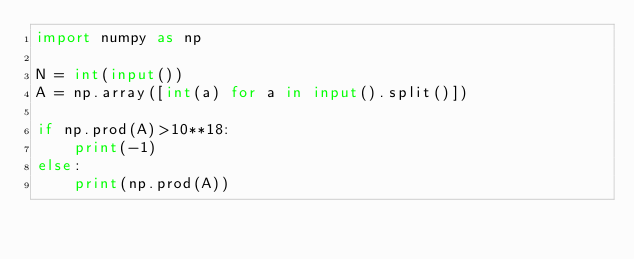<code> <loc_0><loc_0><loc_500><loc_500><_Python_>import numpy as np

N = int(input())
A = np.array([int(a) for a in input().split()])

if np.prod(A)>10**18:
    print(-1)
else:
    print(np.prod(A))</code> 